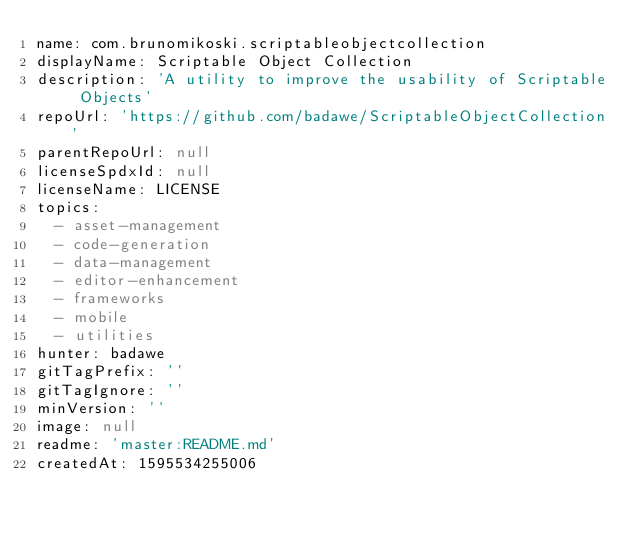<code> <loc_0><loc_0><loc_500><loc_500><_YAML_>name: com.brunomikoski.scriptableobjectcollection
displayName: Scriptable Object Collection
description: 'A utility to improve the usability of Scriptable Objects'
repoUrl: 'https://github.com/badawe/ScriptableObjectCollection'
parentRepoUrl: null
licenseSpdxId: null
licenseName: LICENSE
topics:
  - asset-management
  - code-generation
  - data-management
  - editor-enhancement
  - frameworks
  - mobile
  - utilities
hunter: badawe
gitTagPrefix: ''
gitTagIgnore: ''
minVersion: ''
image: null
readme: 'master:README.md'
createdAt: 1595534255006
</code> 